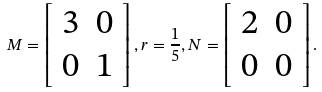<formula> <loc_0><loc_0><loc_500><loc_500>M = \left [ \begin{array} { c c } 3 & 0 \\ 0 & 1 \\ \end{array} \right ] , r = \frac { 1 } { 5 } , N = \left [ \begin{array} { c c } 2 & 0 \\ 0 & 0 \\ \end{array} \right ] .</formula> 